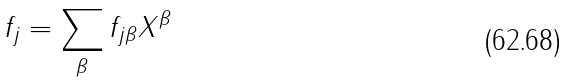Convert formula to latex. <formula><loc_0><loc_0><loc_500><loc_500>f _ { j } = \sum _ { \beta } f _ { j \beta } X ^ { \beta }</formula> 